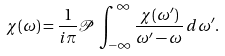<formula> <loc_0><loc_0><loc_500><loc_500>\chi ( \omega ) = { \frac { 1 } { i \pi } } { \mathcal { P } } \, \int _ { - \infty } ^ { \infty } { \frac { \chi ( \omega ^ { \prime } ) } { \omega ^ { \prime } - \omega } } \, d \omega ^ { \prime } .</formula> 